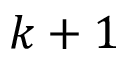Convert formula to latex. <formula><loc_0><loc_0><loc_500><loc_500>k + 1</formula> 